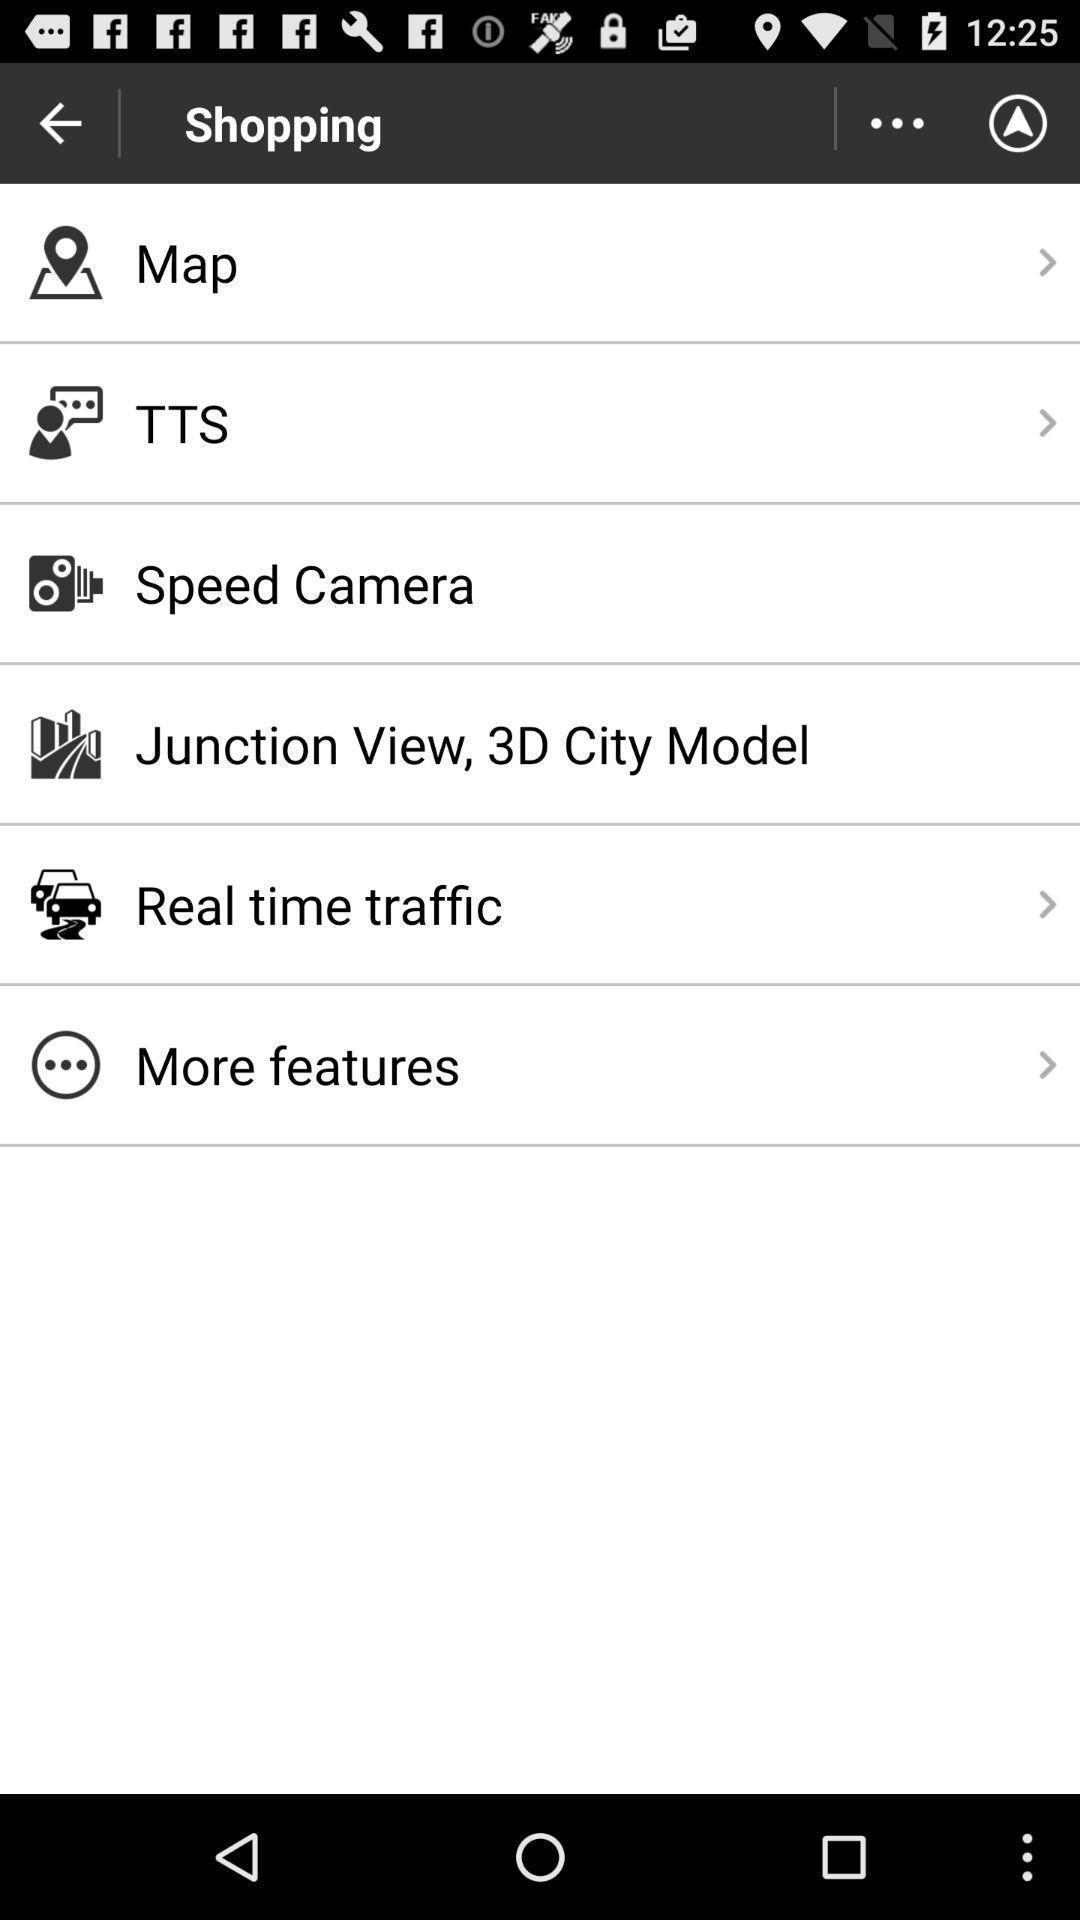Tell me what you see in this picture. Page showing travel setting options. 